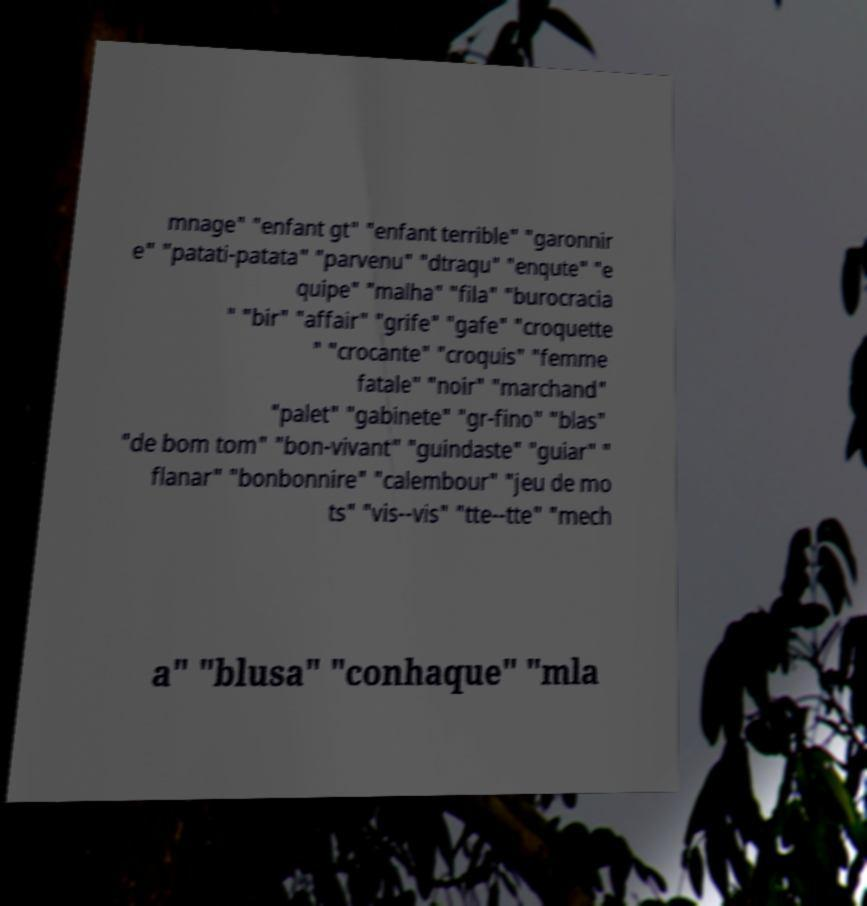Please read and relay the text visible in this image. What does it say? mnage" "enfant gt" "enfant terrible" "garonnir e" "patati-patata" "parvenu" "dtraqu" "enqute" "e quipe" "malha" "fila" "burocracia " "bir" "affair" "grife" "gafe" "croquette " "crocante" "croquis" "femme fatale" "noir" "marchand" "palet" "gabinete" "gr-fino" "blas" "de bom tom" "bon-vivant" "guindaste" "guiar" " flanar" "bonbonnire" "calembour" "jeu de mo ts" "vis--vis" "tte--tte" "mech a" "blusa" "conhaque" "mla 